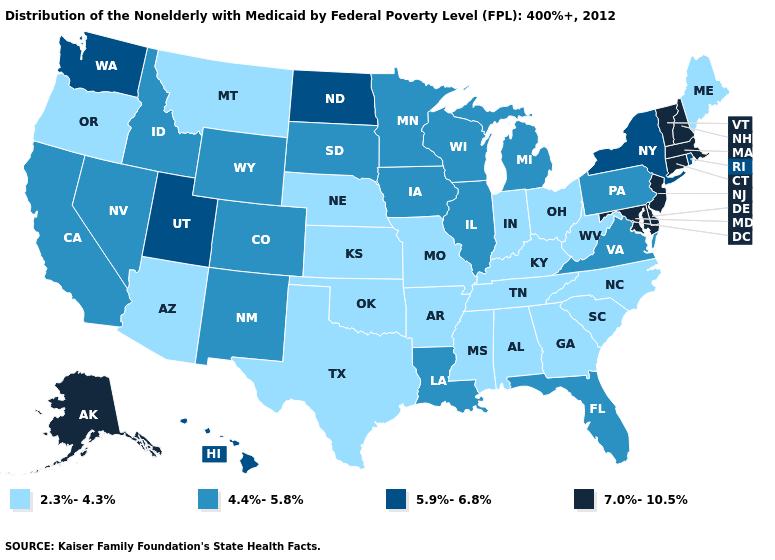Which states have the highest value in the USA?
Concise answer only. Alaska, Connecticut, Delaware, Maryland, Massachusetts, New Hampshire, New Jersey, Vermont. Does Hawaii have the lowest value in the USA?
Quick response, please. No. Name the states that have a value in the range 5.9%-6.8%?
Give a very brief answer. Hawaii, New York, North Dakota, Rhode Island, Utah, Washington. What is the value of Arkansas?
Be succinct. 2.3%-4.3%. What is the value of Colorado?
Short answer required. 4.4%-5.8%. Name the states that have a value in the range 2.3%-4.3%?
Keep it brief. Alabama, Arizona, Arkansas, Georgia, Indiana, Kansas, Kentucky, Maine, Mississippi, Missouri, Montana, Nebraska, North Carolina, Ohio, Oklahoma, Oregon, South Carolina, Tennessee, Texas, West Virginia. Name the states that have a value in the range 7.0%-10.5%?
Concise answer only. Alaska, Connecticut, Delaware, Maryland, Massachusetts, New Hampshire, New Jersey, Vermont. What is the value of Wyoming?
Answer briefly. 4.4%-5.8%. What is the value of Vermont?
Write a very short answer. 7.0%-10.5%. What is the lowest value in the South?
Quick response, please. 2.3%-4.3%. Among the states that border Oklahoma , does New Mexico have the lowest value?
Concise answer only. No. Among the states that border Minnesota , does South Dakota have the highest value?
Quick response, please. No. Name the states that have a value in the range 5.9%-6.8%?
Short answer required. Hawaii, New York, North Dakota, Rhode Island, Utah, Washington. Does Massachusetts have the same value as Michigan?
Be succinct. No. What is the value of North Carolina?
Write a very short answer. 2.3%-4.3%. 